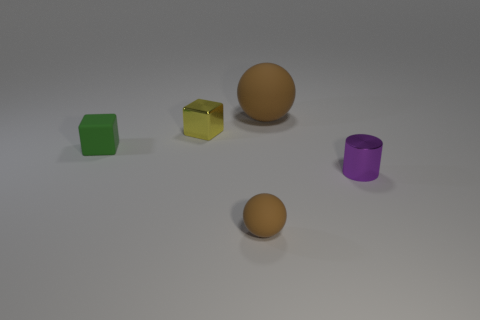Is there any other thing that is the same shape as the purple object?
Give a very brief answer. No. What is the material of the big ball?
Offer a terse response. Rubber. Does the ball that is to the left of the large brown matte sphere have the same color as the thing behind the metallic cube?
Give a very brief answer. Yes. Is the number of tiny green objects that are to the left of the shiny cylinder greater than the number of yellow metal cylinders?
Offer a terse response. Yes. What number of other objects are there of the same color as the metallic cylinder?
Your answer should be very brief. 0. There is a brown thing that is behind the purple cylinder; does it have the same size as the tiny green matte block?
Your answer should be very brief. No. Are there any green blocks that have the same size as the green rubber thing?
Provide a succinct answer. No. What color is the tiny object right of the big brown rubber sphere?
Your response must be concise. Purple. There is a object that is in front of the large brown ball and behind the small matte cube; what is its shape?
Your response must be concise. Cube. How many yellow objects are the same shape as the tiny green matte object?
Offer a very short reply. 1. 